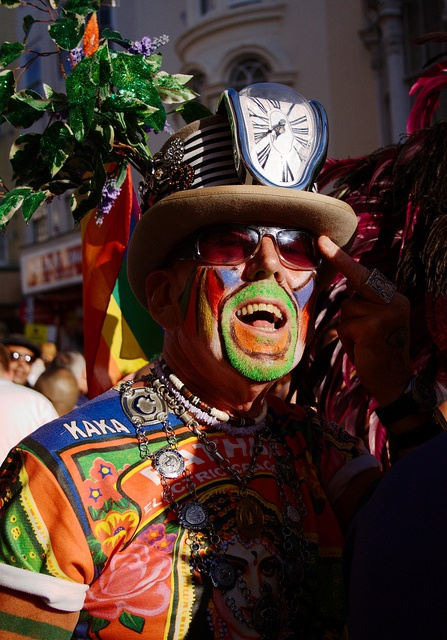Describe the objects in this image and their specific colors. I can see people in olive, black, maroon, lightgray, and red tones, clock in olive, white, gray, and darkgray tones, people in olive, lightgray, maroon, black, and tan tones, people in olive, gray, brown, tan, and maroon tones, and people in olive, black, salmon, brown, and maroon tones in this image. 